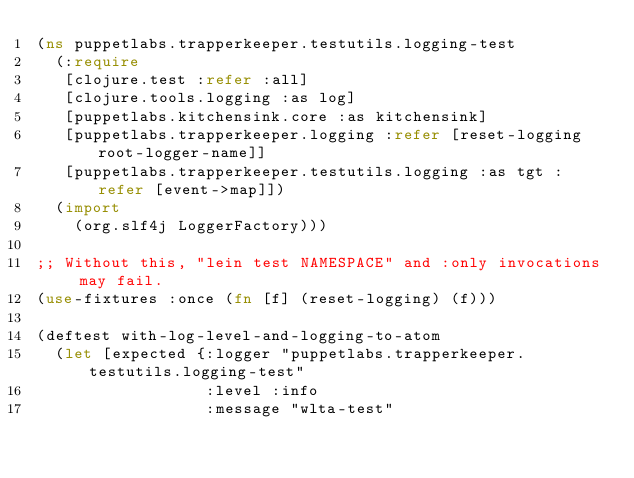<code> <loc_0><loc_0><loc_500><loc_500><_Clojure_>(ns puppetlabs.trapperkeeper.testutils.logging-test
  (:require
   [clojure.test :refer :all]
   [clojure.tools.logging :as log]
   [puppetlabs.kitchensink.core :as kitchensink]
   [puppetlabs.trapperkeeper.logging :refer [reset-logging root-logger-name]]
   [puppetlabs.trapperkeeper.testutils.logging :as tgt :refer [event->map]])
  (import
    (org.slf4j LoggerFactory)))

;; Without this, "lein test NAMESPACE" and :only invocations may fail.
(use-fixtures :once (fn [f] (reset-logging) (f)))

(deftest with-log-level-and-logging-to-atom
  (let [expected {:logger "puppetlabs.trapperkeeper.testutils.logging-test"
                  :level :info
                  :message "wlta-test"</code> 